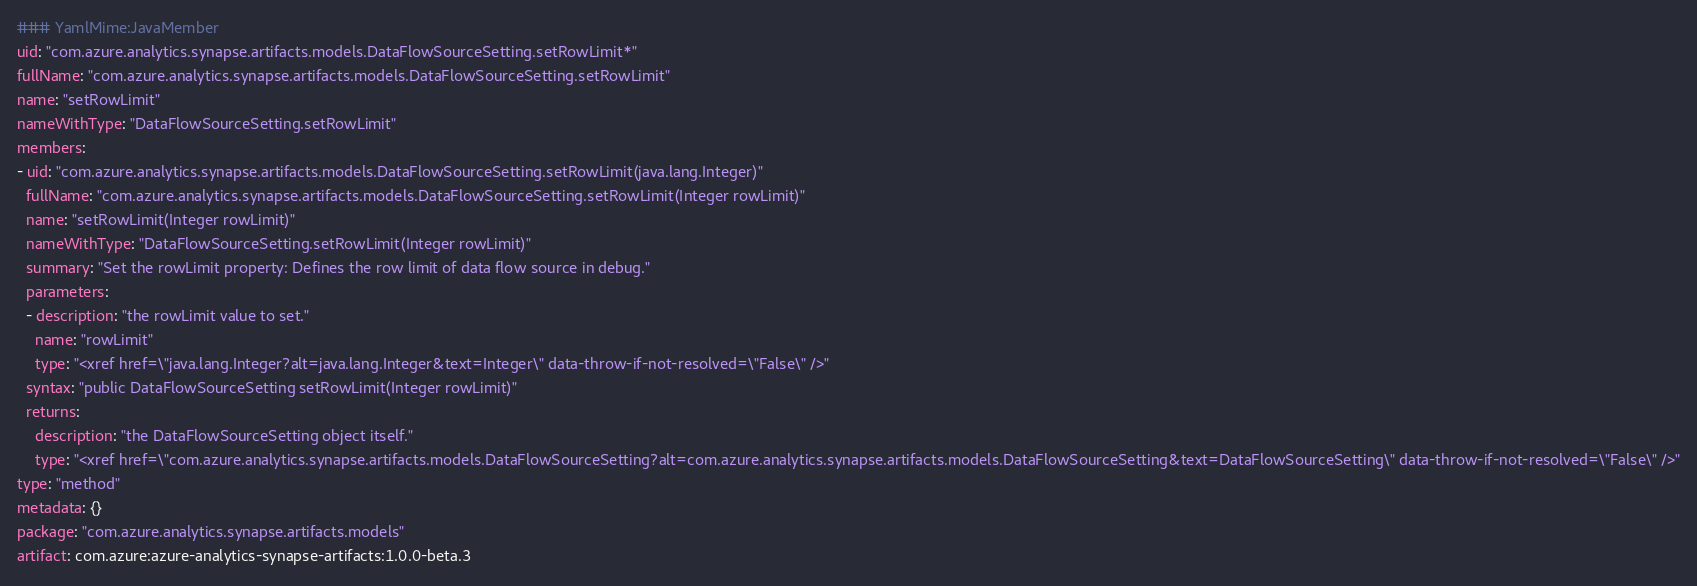<code> <loc_0><loc_0><loc_500><loc_500><_YAML_>### YamlMime:JavaMember
uid: "com.azure.analytics.synapse.artifacts.models.DataFlowSourceSetting.setRowLimit*"
fullName: "com.azure.analytics.synapse.artifacts.models.DataFlowSourceSetting.setRowLimit"
name: "setRowLimit"
nameWithType: "DataFlowSourceSetting.setRowLimit"
members:
- uid: "com.azure.analytics.synapse.artifacts.models.DataFlowSourceSetting.setRowLimit(java.lang.Integer)"
  fullName: "com.azure.analytics.synapse.artifacts.models.DataFlowSourceSetting.setRowLimit(Integer rowLimit)"
  name: "setRowLimit(Integer rowLimit)"
  nameWithType: "DataFlowSourceSetting.setRowLimit(Integer rowLimit)"
  summary: "Set the rowLimit property: Defines the row limit of data flow source in debug."
  parameters:
  - description: "the rowLimit value to set."
    name: "rowLimit"
    type: "<xref href=\"java.lang.Integer?alt=java.lang.Integer&text=Integer\" data-throw-if-not-resolved=\"False\" />"
  syntax: "public DataFlowSourceSetting setRowLimit(Integer rowLimit)"
  returns:
    description: "the DataFlowSourceSetting object itself."
    type: "<xref href=\"com.azure.analytics.synapse.artifacts.models.DataFlowSourceSetting?alt=com.azure.analytics.synapse.artifacts.models.DataFlowSourceSetting&text=DataFlowSourceSetting\" data-throw-if-not-resolved=\"False\" />"
type: "method"
metadata: {}
package: "com.azure.analytics.synapse.artifacts.models"
artifact: com.azure:azure-analytics-synapse-artifacts:1.0.0-beta.3
</code> 